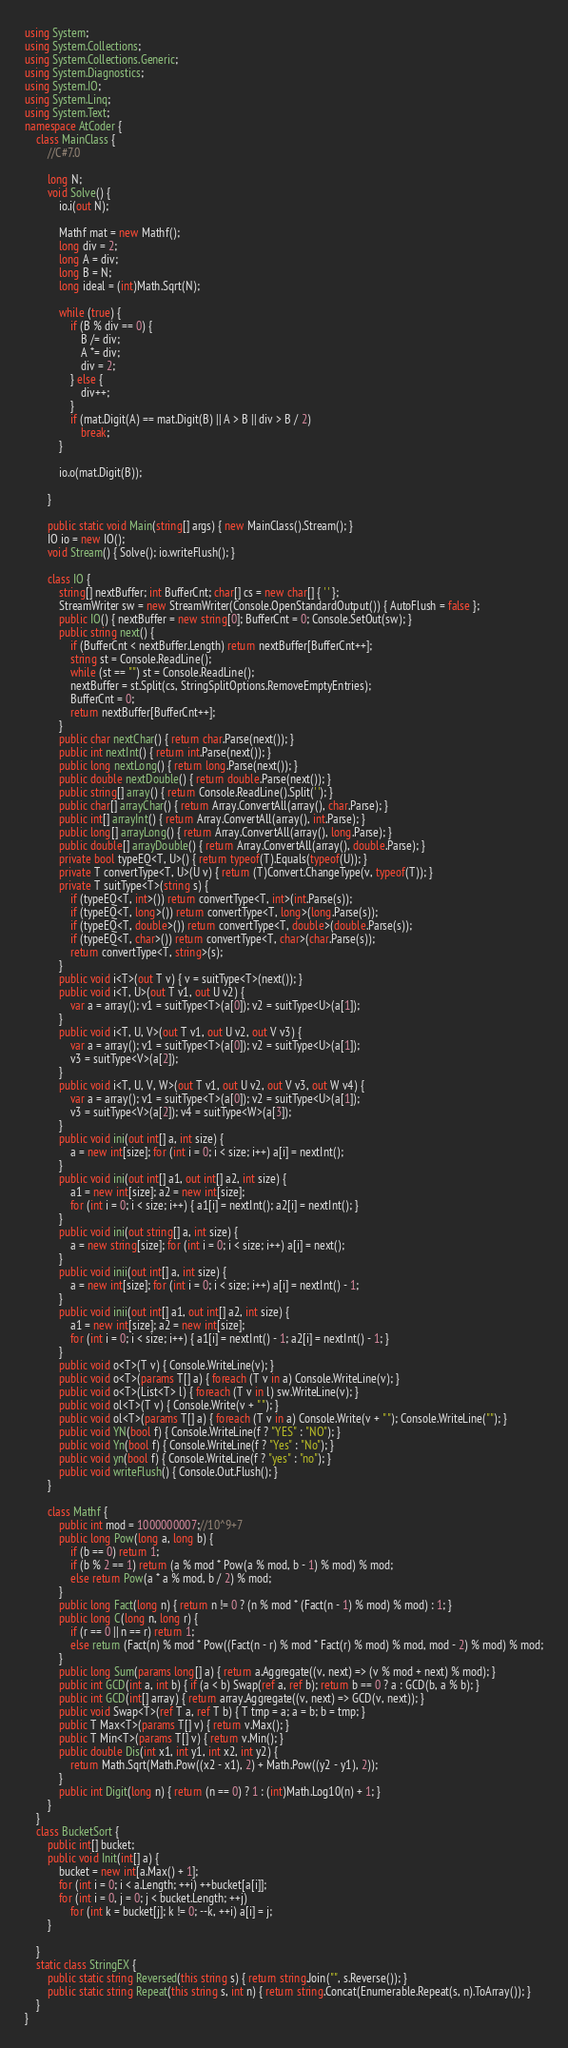Convert code to text. <code><loc_0><loc_0><loc_500><loc_500><_C#_>using System;
using System.Collections;
using System.Collections.Generic;
using System.Diagnostics;
using System.IO;
using System.Linq;
using System.Text;
namespace AtCoder {
    class MainClass {
        //C#7.0

        long N;
        void Solve() {
            io.i(out N);

            Mathf mat = new Mathf();
            long div = 2;
            long A = div;
            long B = N;
            long ideal = (int)Math.Sqrt(N);

            while (true) {
                if (B % div == 0) {
                    B /= div;
                    A *= div;
                    div = 2;
                } else {
                    div++;
                }
                if (mat.Digit(A) == mat.Digit(B) || A > B || div > B / 2)
                    break;
            }

            io.o(mat.Digit(B));

        }

        public static void Main(string[] args) { new MainClass().Stream(); }
        IO io = new IO();
        void Stream() { Solve(); io.writeFlush(); }

        class IO {
            string[] nextBuffer; int BufferCnt; char[] cs = new char[] { ' ' };
            StreamWriter sw = new StreamWriter(Console.OpenStandardOutput()) { AutoFlush = false };
            public IO() { nextBuffer = new string[0]; BufferCnt = 0; Console.SetOut(sw); }
            public string next() {
                if (BufferCnt < nextBuffer.Length) return nextBuffer[BufferCnt++];
                string st = Console.ReadLine();
                while (st == "") st = Console.ReadLine();
                nextBuffer = st.Split(cs, StringSplitOptions.RemoveEmptyEntries);
                BufferCnt = 0;
                return nextBuffer[BufferCnt++];
            }
            public char nextChar() { return char.Parse(next()); }
            public int nextInt() { return int.Parse(next()); }
            public long nextLong() { return long.Parse(next()); }
            public double nextDouble() { return double.Parse(next()); }
            public string[] array() { return Console.ReadLine().Split(' '); }
            public char[] arrayChar() { return Array.ConvertAll(array(), char.Parse); }
            public int[] arrayInt() { return Array.ConvertAll(array(), int.Parse); }
            public long[] arrayLong() { return Array.ConvertAll(array(), long.Parse); }
            public double[] arrayDouble() { return Array.ConvertAll(array(), double.Parse); }
            private bool typeEQ<T, U>() { return typeof(T).Equals(typeof(U)); }
            private T convertType<T, U>(U v) { return (T)Convert.ChangeType(v, typeof(T)); }
            private T suitType<T>(string s) {
                if (typeEQ<T, int>()) return convertType<T, int>(int.Parse(s));
                if (typeEQ<T, long>()) return convertType<T, long>(long.Parse(s));
                if (typeEQ<T, double>()) return convertType<T, double>(double.Parse(s));
                if (typeEQ<T, char>()) return convertType<T, char>(char.Parse(s));
                return convertType<T, string>(s);
            }
            public void i<T>(out T v) { v = suitType<T>(next()); }
            public void i<T, U>(out T v1, out U v2) {
                var a = array(); v1 = suitType<T>(a[0]); v2 = suitType<U>(a[1]);
            }
            public void i<T, U, V>(out T v1, out U v2, out V v3) {
                var a = array(); v1 = suitType<T>(a[0]); v2 = suitType<U>(a[1]);
                v3 = suitType<V>(a[2]);
            }
            public void i<T, U, V, W>(out T v1, out U v2, out V v3, out W v4) {
                var a = array(); v1 = suitType<T>(a[0]); v2 = suitType<U>(a[1]);
                v3 = suitType<V>(a[2]); v4 = suitType<W>(a[3]);
            }
            public void ini(out int[] a, int size) {
                a = new int[size]; for (int i = 0; i < size; i++) a[i] = nextInt();
            }
            public void ini(out int[] a1, out int[] a2, int size) {
                a1 = new int[size]; a2 = new int[size];
                for (int i = 0; i < size; i++) { a1[i] = nextInt(); a2[i] = nextInt(); }
            }
            public void ini(out string[] a, int size) {
                a = new string[size]; for (int i = 0; i < size; i++) a[i] = next();
            }
            public void inii(out int[] a, int size) {
                a = new int[size]; for (int i = 0; i < size; i++) a[i] = nextInt() - 1;
            }
            public void inii(out int[] a1, out int[] a2, int size) {
                a1 = new int[size]; a2 = new int[size];
                for (int i = 0; i < size; i++) { a1[i] = nextInt() - 1; a2[i] = nextInt() - 1; }
            }
            public void o<T>(T v) { Console.WriteLine(v); }
            public void o<T>(params T[] a) { foreach (T v in a) Console.WriteLine(v); }
            public void o<T>(List<T> l) { foreach (T v in l) sw.WriteLine(v); }
            public void ol<T>(T v) { Console.Write(v + " "); }
            public void ol<T>(params T[] a) { foreach (T v in a) Console.Write(v + " "); Console.WriteLine(""); }
            public void YN(bool f) { Console.WriteLine(f ? "YES" : "NO"); }
            public void Yn(bool f) { Console.WriteLine(f ? "Yes" : "No"); }
            public void yn(bool f) { Console.WriteLine(f ? "yes" : "no"); }
            public void writeFlush() { Console.Out.Flush(); }
        }

        class Mathf {
            public int mod = 1000000007;//10^9+7
            public long Pow(long a, long b) {
                if (b == 0) return 1;
                if (b % 2 == 1) return (a % mod * Pow(a % mod, b - 1) % mod) % mod;
                else return Pow(a * a % mod, b / 2) % mod;
            }
            public long Fact(long n) { return n != 0 ? (n % mod * (Fact(n - 1) % mod) % mod) : 1; }
            public long C(long n, long r) {
                if (r == 0 || n == r) return 1;
                else return (Fact(n) % mod * Pow((Fact(n - r) % mod * Fact(r) % mod) % mod, mod - 2) % mod) % mod;
            }
            public long Sum(params long[] a) { return a.Aggregate((v, next) => (v % mod + next) % mod); }
            public int GCD(int a, int b) { if (a < b) Swap(ref a, ref b); return b == 0 ? a : GCD(b, a % b); }
            public int GCD(int[] array) { return array.Aggregate((v, next) => GCD(v, next)); }
            public void Swap<T>(ref T a, ref T b) { T tmp = a; a = b; b = tmp; }
            public T Max<T>(params T[] v) { return v.Max(); }
            public T Min<T>(params T[] v) { return v.Min(); }
            public double Dis(int x1, int y1, int x2, int y2) {
                return Math.Sqrt(Math.Pow((x2 - x1), 2) + Math.Pow((y2 - y1), 2));
            }
            public int Digit(long n) { return (n == 0) ? 1 : (int)Math.Log10(n) + 1; }
        }
    }
    class BucketSort {
        public int[] bucket;
        public void Init(int[] a) {
            bucket = new int[a.Max() + 1];
            for (int i = 0; i < a.Length; ++i) ++bucket[a[i]];
            for (int i = 0, j = 0; j < bucket.Length; ++j)
                for (int k = bucket[j]; k != 0; --k, ++i) a[i] = j;
        }

    }
    static class StringEX {
        public static string Reversed(this string s) { return string.Join("", s.Reverse()); }
        public static string Repeat(this string s, int n) { return string.Concat(Enumerable.Repeat(s, n).ToArray()); }
    }
}</code> 